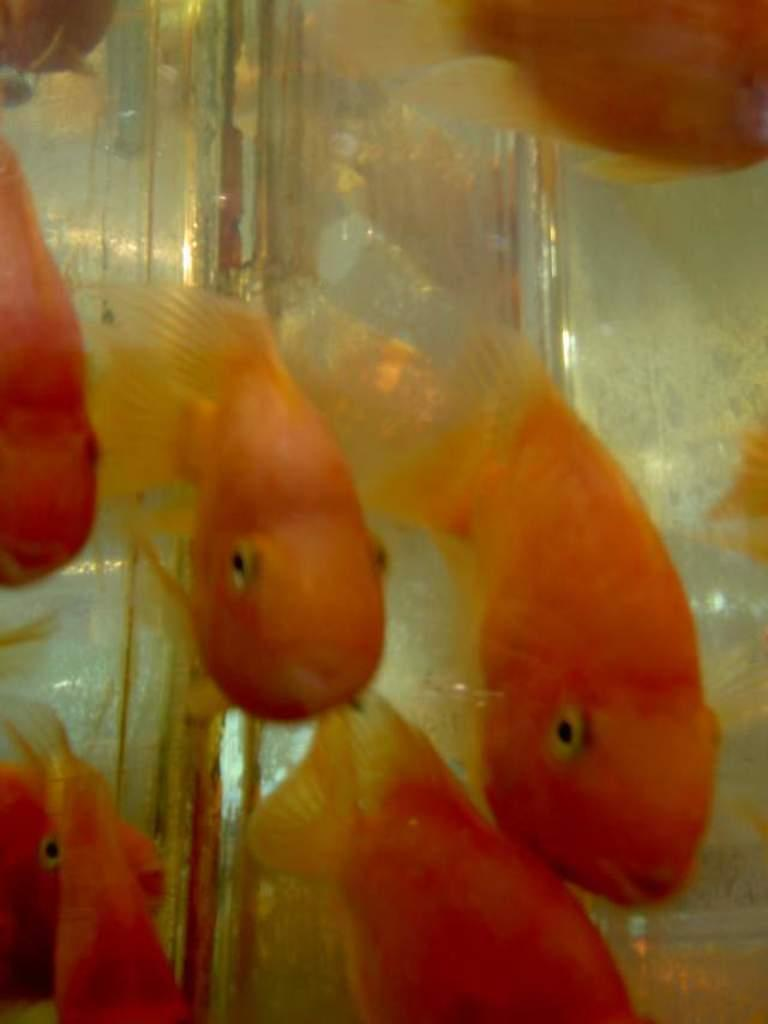What type of animals are in the image? There are golden fish in the image. Can you describe the background of the image? The background of the image is blurred. What type of roof can be seen on the fish in the image? There is no roof present on the fish in the image, as they are aquatic animals. 